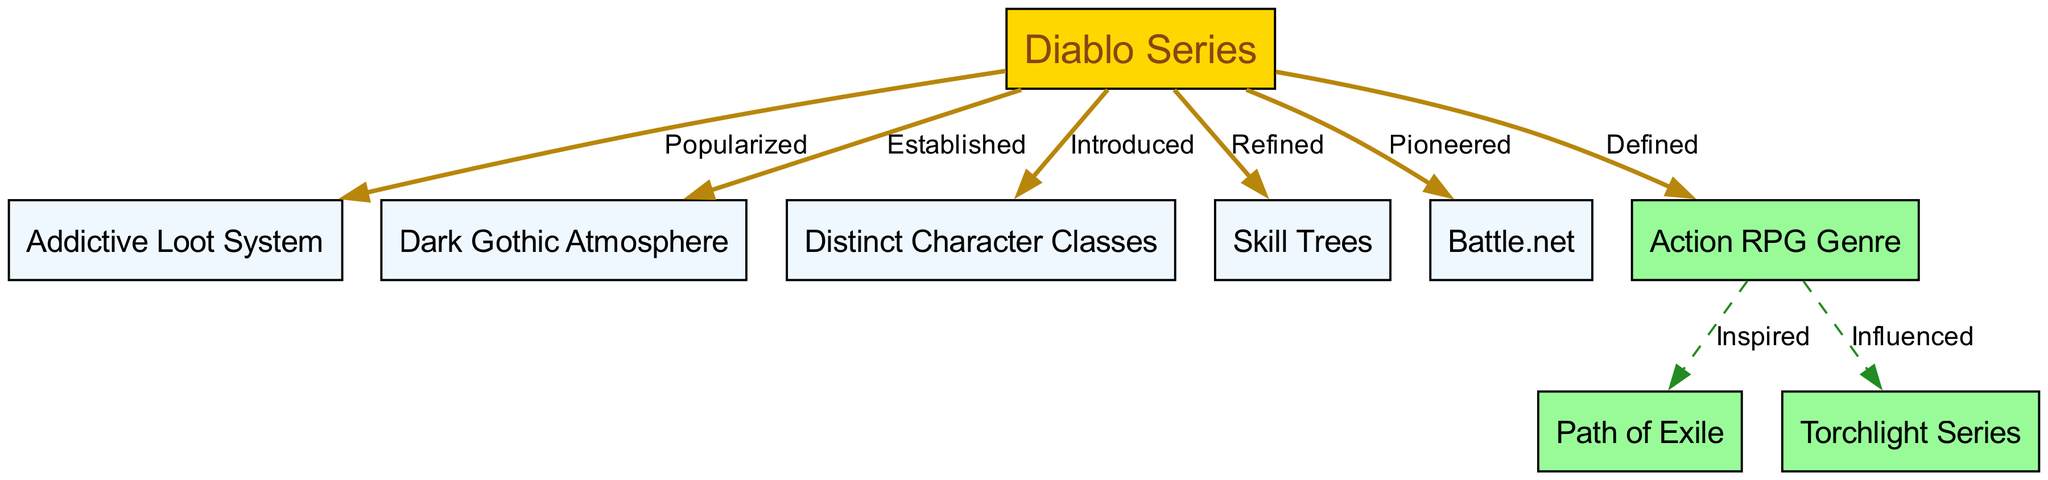What does the Diablo series popularize? The diagram shows that the Diablo Series popularized the "Addictive Loot System". This is connected by an edge labeled "Popularized" from "Diablo Series" to "Addictive Loot System".
Answer: Addictive Loot System How many distinct character classes were introduced by Diablo? The diagram indicates that Diablo introduced "Distinct Character Classes". Since it does not list specific classes or numbers, the precise count is not available, but the phrase remains unchanged in the output.
Answer: Distinct Character Classes What system does the Diablo series refine? The edge from "Diablo Series" to "Skill Trees" is labeled "Refined", indicating that the Diablo series contributed to refining this particular system.
Answer: Skill Trees Which multiplayer platform did Diablo pioneer? According to the diagram, the Diablo Series pioneered "Battle.net", as signaled by the edge labeled "Pioneered" leading from "Diablo Series" to "Battle.net".
Answer: Battle.net What game did the Action RPG genre inspire? The diagram shows that the "Action RPG Genre" inspired "Path of Exile", as seen in the edge labeled "Inspired" connecting "Action RPG Genre" to "Path of Exile".
Answer: Path of Exile How many nodes are there in total on the diagram? By counting the nodes listed in the diagram, we can see there are eight total nodes: "Diablo Series", "Addictive Loot System", "Dark Gothic Atmosphere", "Distinct Character Classes", "Skill Trees", "Battle.net", "Action RPG Genre", "Path of Exile", and "Torchlight Series".
Answer: Eight Which concept is influenced by the Action RPG genre? The diagram indicates that the "Torchlight Series" is influenced by the "Action RPG Genre" as indicated by the edge labeled "Influenced" connecting them.
Answer: Torchlight Series What type of atmosphere does the Diablo series establish? The connection labeled "Established" in the diagram from "Diablo Series" to "Dark Gothic Atmosphere" indicates the type of atmosphere that it establishes.
Answer: Dark Gothic Atmosphere What labels are used for edges stemming from the Diablo series? The labels illustrating the relationships from the Diablo series to other parts of the diagram include "Popularized", "Established", "Introduced", "Refined", and "Pioneered".
Answer: Popularized, Established, Introduced, Refined, Pioneered 